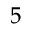<formula> <loc_0><loc_0><loc_500><loc_500>^ { 5 }</formula> 